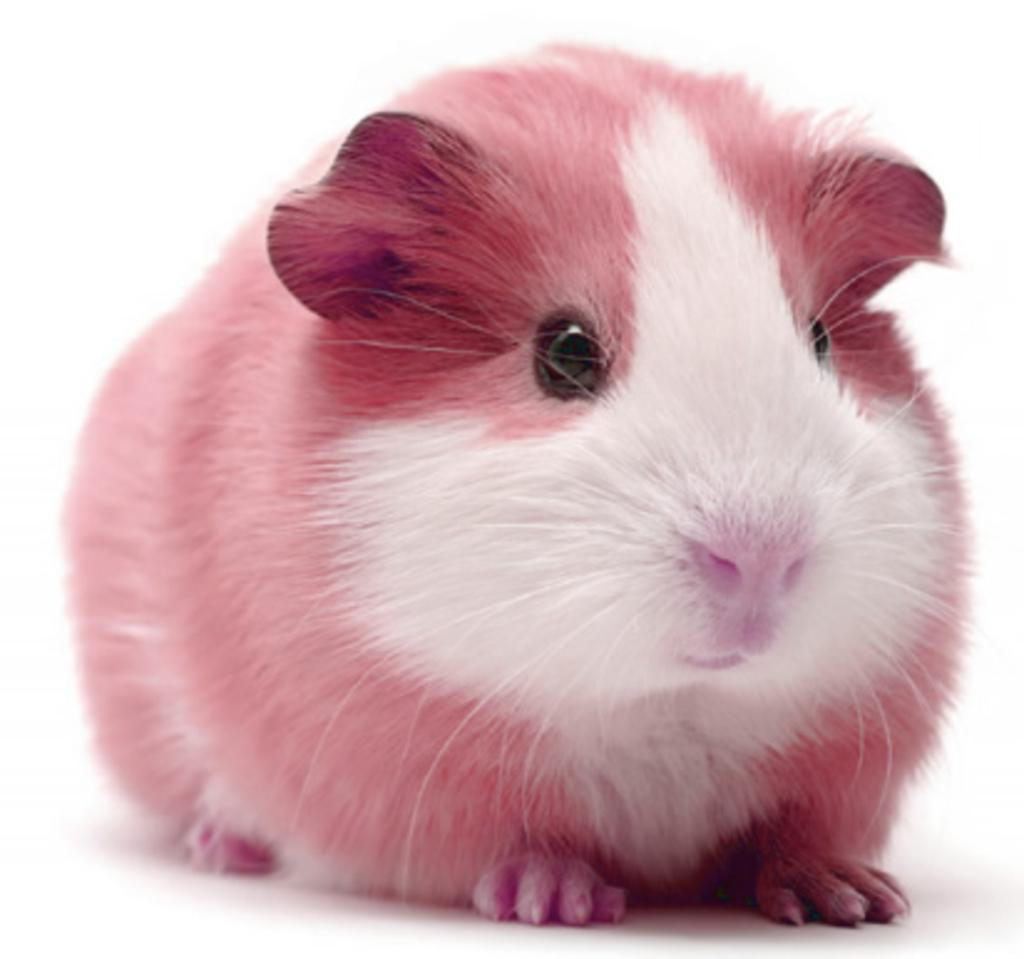What animal is present in the image? There is a rat in the picture. Can you describe the rat's fur color? The rat has white and pink color fur. What type of surface can be seen in the image? There is a white color surface in the picture. What type of street is visible in the image? There is no street present in the image; it features a rat with white and pink fur on a white surface. 